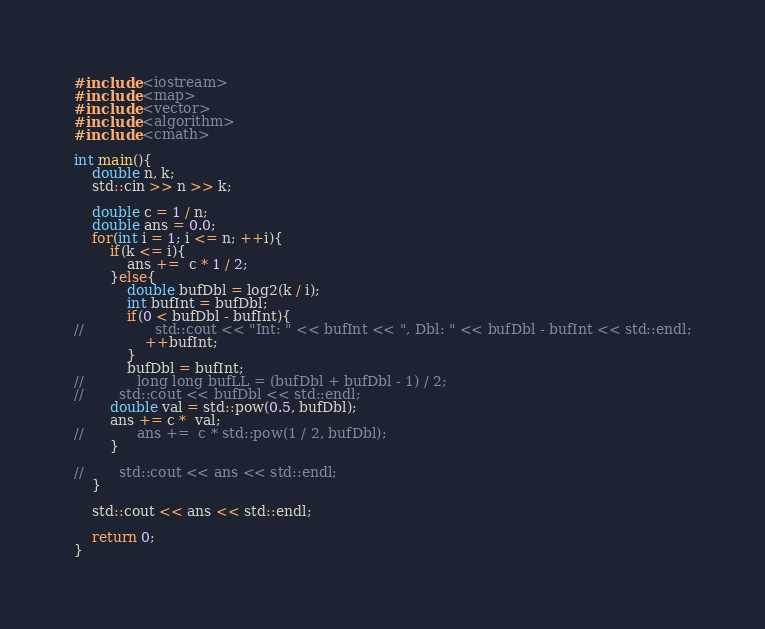Convert code to text. <code><loc_0><loc_0><loc_500><loc_500><_C++_>#include <iostream>
#include <map>
#include <vector>
#include <algorithm>
#include <cmath>

int main(){
    double n, k;
    std::cin >> n >> k;

    double c = 1 / n;
    double ans = 0.0;
    for(int i = 1; i <= n; ++i){
        if(k <= i){
            ans +=  c * 1 / 2;
        }else{
            double bufDbl = log2(k / i);
            int bufInt = bufDbl;
            if(0 < bufDbl - bufInt){
//                std::cout << "Int: " << bufInt << ", Dbl: " << bufDbl - bufInt << std::endl;
                ++bufInt;
            }
            bufDbl = bufInt;
//            long long bufLL = (bufDbl + bufDbl - 1) / 2;
//        std::cout << bufDbl << std::endl;
        double val = std::pow(0.5, bufDbl);
        ans += c *  val;
//            ans +=  c * std::pow(1 / 2, bufDbl);
        }

//        std::cout << ans << std::endl;
    }

    std::cout << ans << std::endl;

    return 0;
}
</code> 